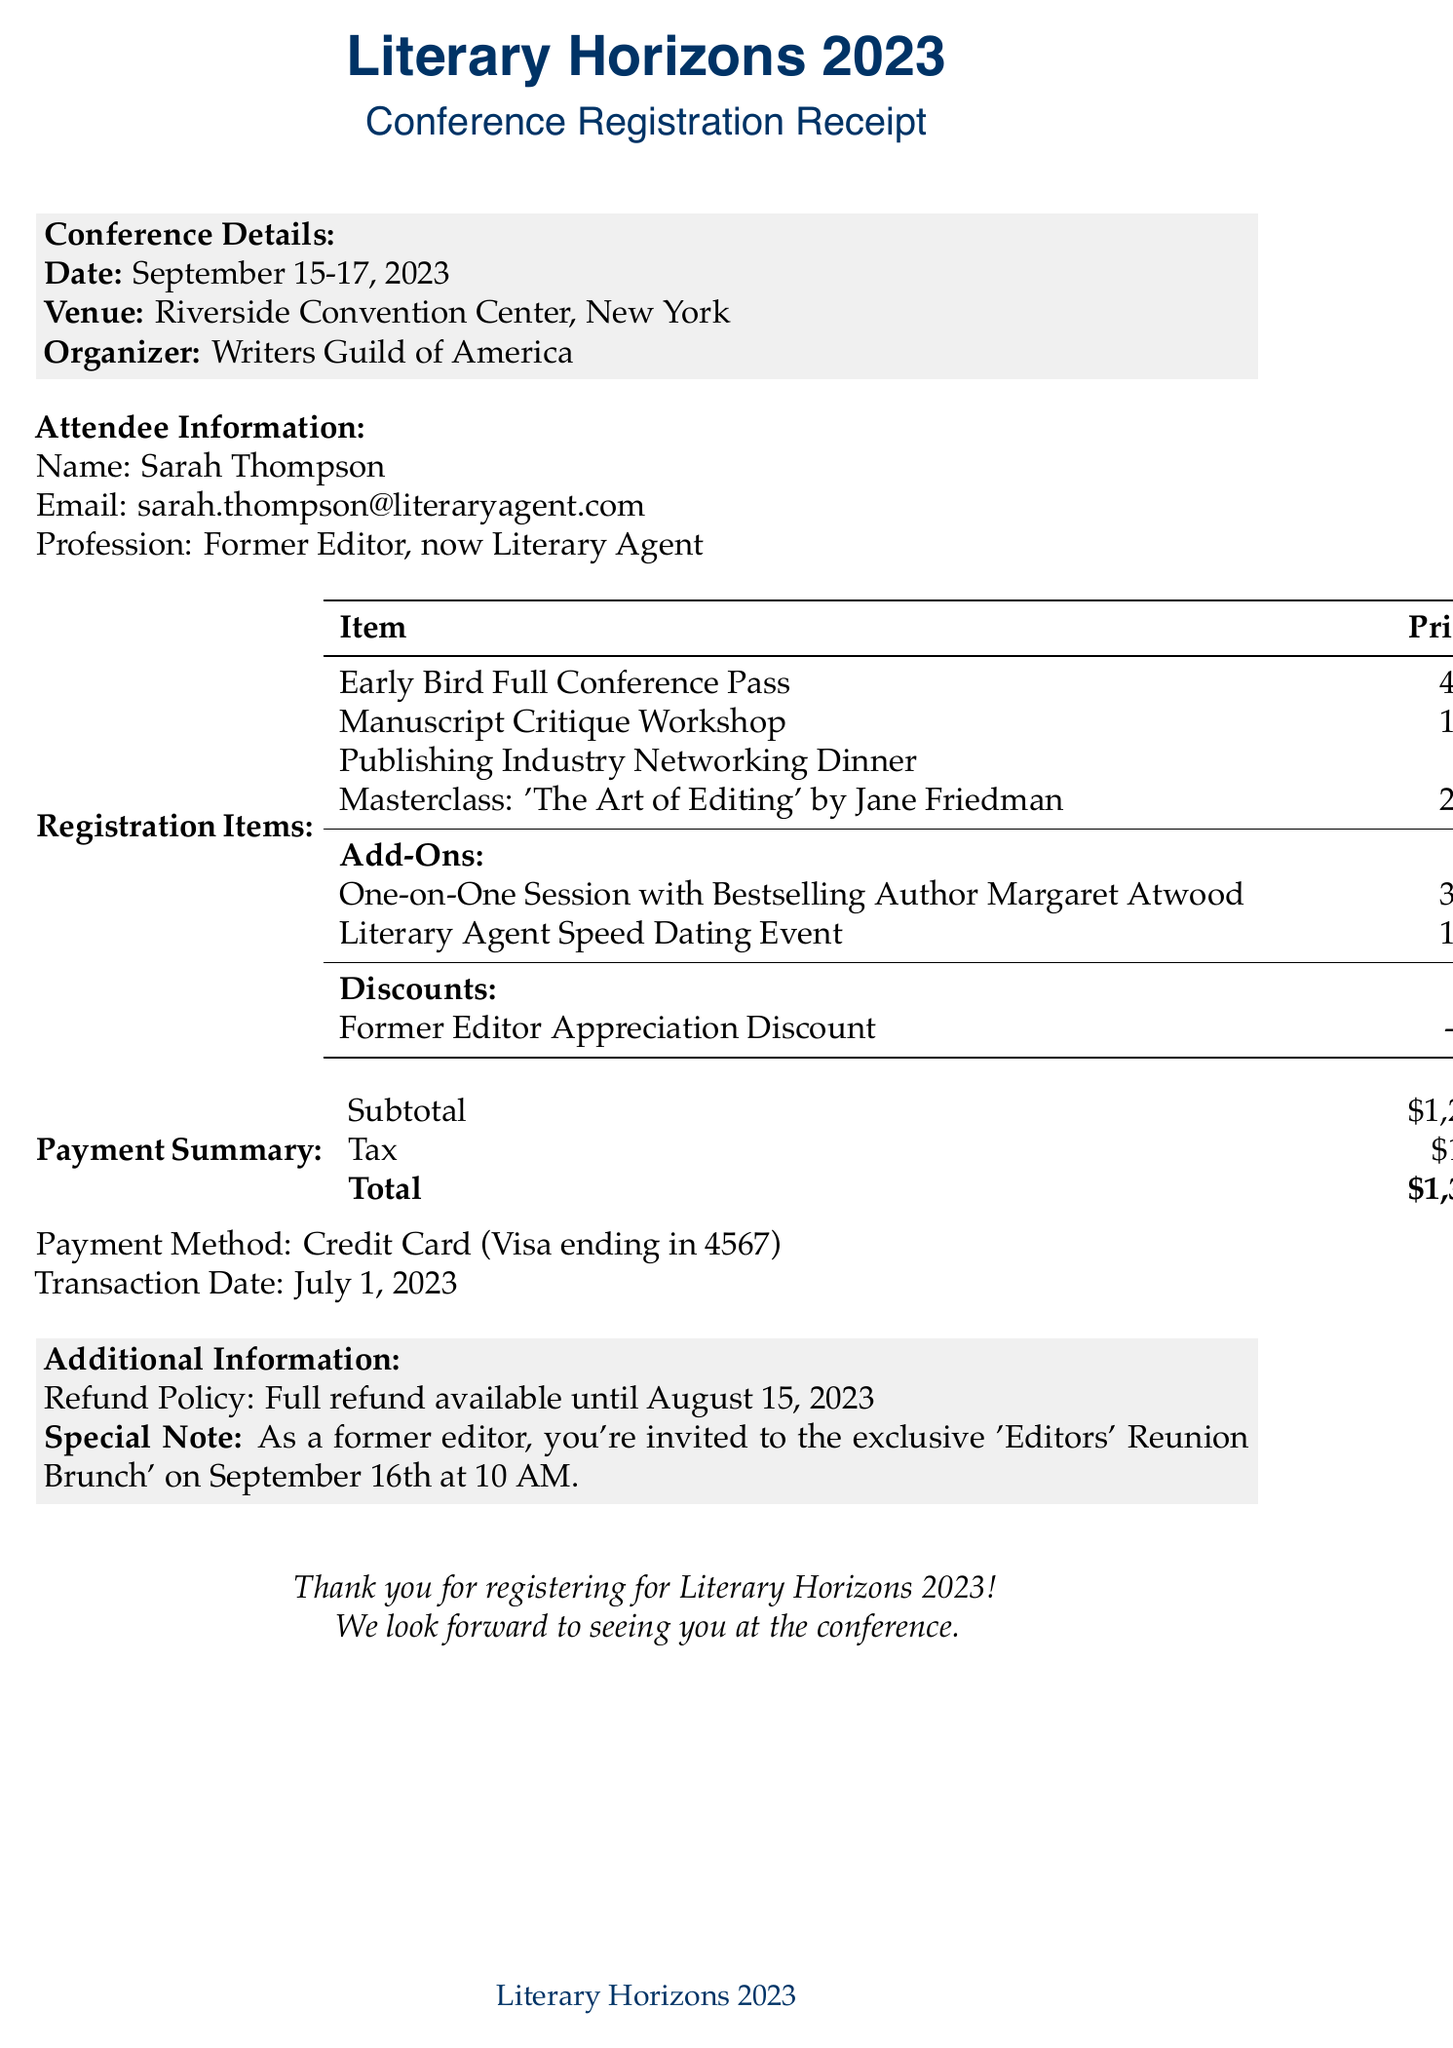What is the total registration amount? The total registration amount is the sum of all items, add-ons, and discounts, which amounts to $1375.92.
Answer: $1,375.92 Who is the organizer of the conference? The organizer of the conference is mentioned in the document as the writers' responsible body.
Answer: Writers Guild of America What is the date of the conference? The date specified in the document indicates when the conference will take place.
Answer: September 15-17, 2023 Which special event is offered exclusively to former editors? The document notes a special event that targets former editors specifically, making it unique to their profession.
Answer: Editors' Reunion Brunch How much is the Manuscript Critique Workshop? The price for this specific workshop is listed in the registration items section, showing the cost for attending.
Answer: $150.00 What discount is applied to the registration? The document describes a specific discount that applies to attendees with a certain background, which is noted clearly.
Answer: Former Editor Appreciation Discount What is the tax amount included in the payment? The document provides details on the payment summary, including a line for tax, showing how much was added.
Answer: $101.92 When is the last date for a full refund? The refund policy lists a specific date until when a full refund can be requested, providing clarity on financial commitments.
Answer: August 15, 2023 What payment method was used for registration? The payment method is clearly mentioned in the document, showing the type of credit card used for the transaction.
Answer: Credit Card (Visa ending in 4567) 